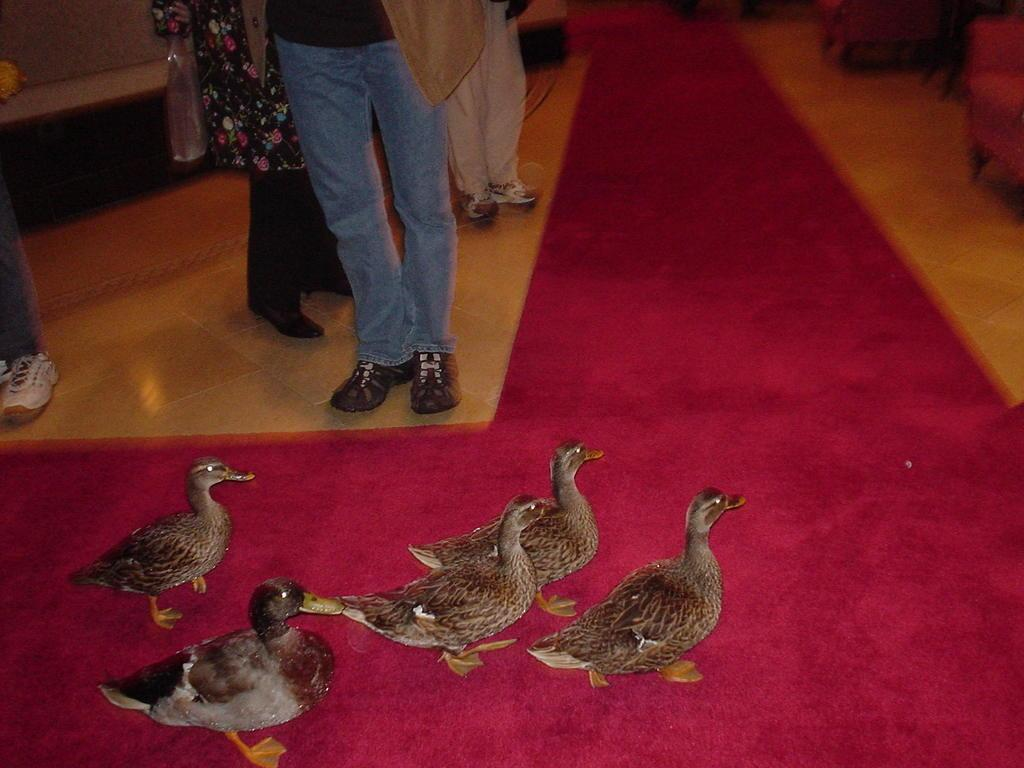What animals are present in the image? There is a group of ducks in the image. What else can be seen in the image besides the ducks? There are people standing on the floor in the image. Where are the chairs located in the image? The chairs are on the right side of the image. Can you see any frogs interacting with the ducks in the image? There are no frogs present in the image; it only features a group of ducks. Are there any fairies visible in the image? There are no fairies present in the image. 